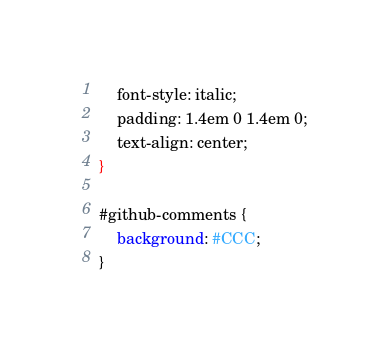Convert code to text. <code><loc_0><loc_0><loc_500><loc_500><_CSS_>    font-style: italic;
    padding: 1.4em 0 1.4em 0;
    text-align: center;
}

#github-comments {
    background: #CCC;
}
</code> 